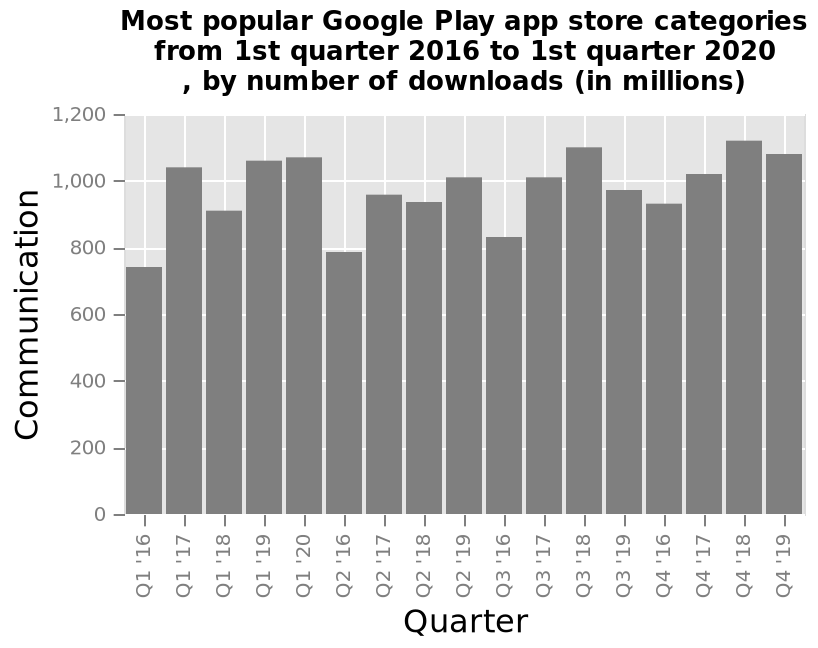<image>
In which year did the increase in app downloads start? The increase in app downloads started in the year 2016. What is the category plotted on the y-axis of the bar graph?  The category plotted on the y-axis of the bar graph is Communication. 